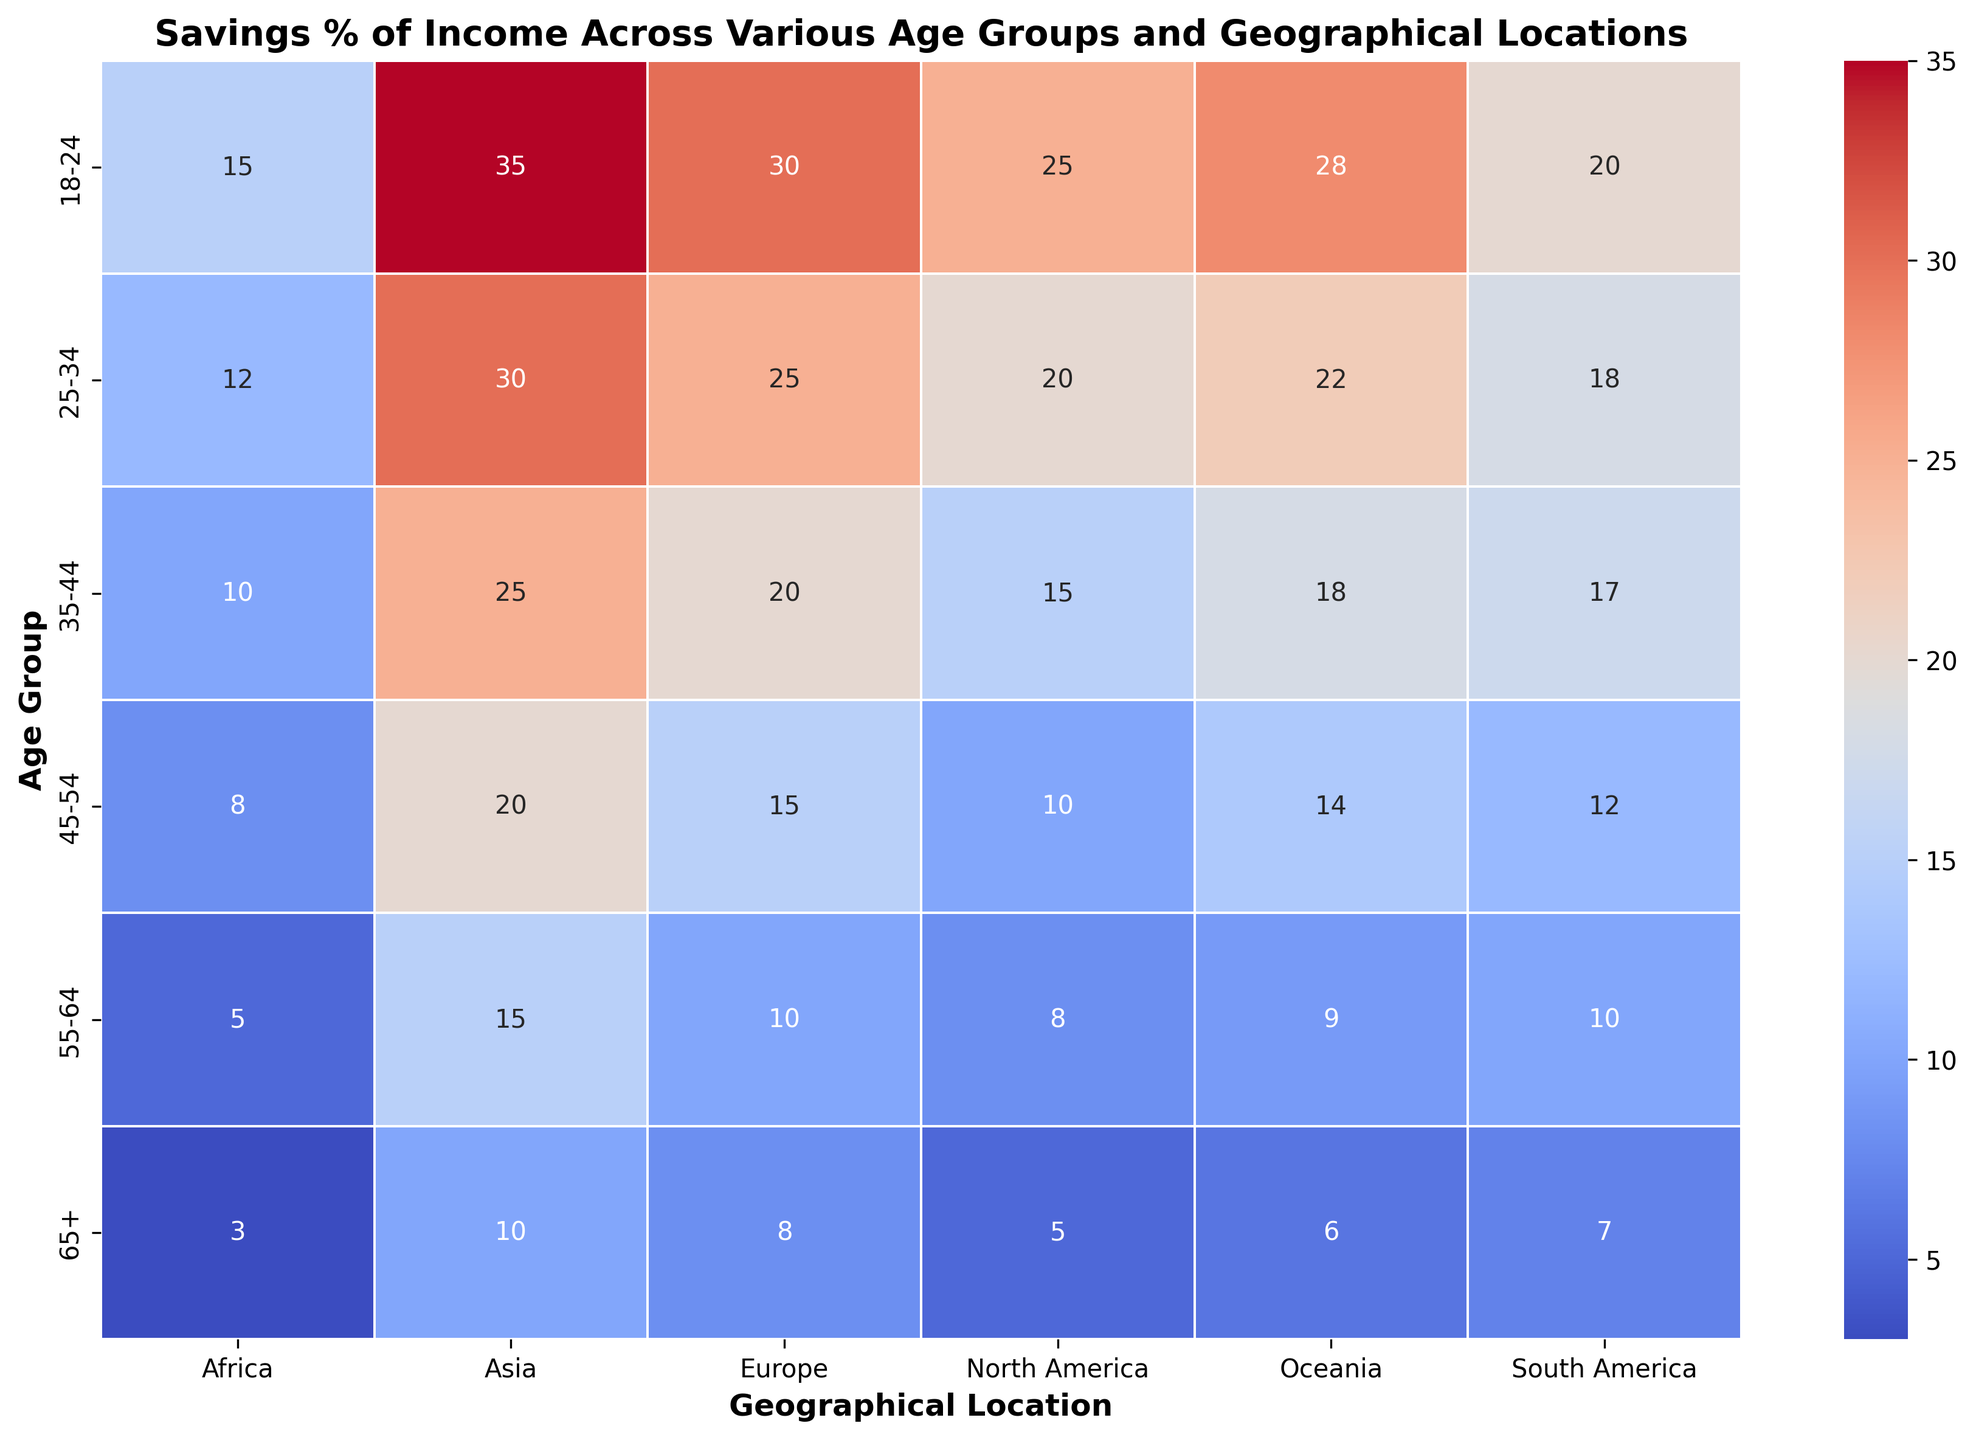What's the highest percentage of income saved by any age group in North America? Looking at the row for North America and all age groups, the highest percentage of income saved is 25% which is for the age group 18-24.
Answer: 25% Which age group in Africa saves the least percentage of their income? By checking the columns corresponding to Africa, the age group 65+ has the least savings percentage, which is 3%.
Answer: 65+ Compare savings percentages between Europe and Asia for the age group 45-54. Which one is higher? The savings percentage for Europe in the 45-54 age group is 15%, while for Asia, it is 20%. Therefore, Asia has a higher savings percentage for this age group.
Answer: Asia What's the difference in savings percentage between the 25-34 age group and the 45-54 age group in Oceania? In Oceania, the savings percentage for the 25-34 age group is 22% and for the 45-54 age group is 14%. The difference is calculated as 22% - 14% = 8%.
Answer: 8% What's the average savings percentage for the age groups 35-44 and 55-64 in South America? The savings percentage for the 35-44 age group in South America is 17%, and for the 55-64 age group is 10%. The average savings is (17% + 10%) / 2 = 13.5%.
Answer: 13.5% In which geographical location do people aged 65+ save the highest percentage of their income? By comparing the savings percentages across all geographical locations for the 65+ age group, Asia has the highest savings percentage of 10%.
Answer: Asia What is the color corresponding to the highest savings percentage in the heatmap? The highest savings percentages are darker shades of red, as visualized in the heatmap for percentages of 35%.
Answer: Dark red What's the total savings percentage across all age groups in Europe? Summing up all savings percentages across age groups in Europe: 30% + 25% + 20% + 15% + 10% + 8% = 108%.
Answer: 108% Which two age groups in North America have the exact difference of 5% in their savings percentages? According to the figure, the 18-24 age group saves 25%, and the 25-34 age group saves 20%. The difference is 25% - 20% = 5%.
Answer: 18-24 and 25-34 